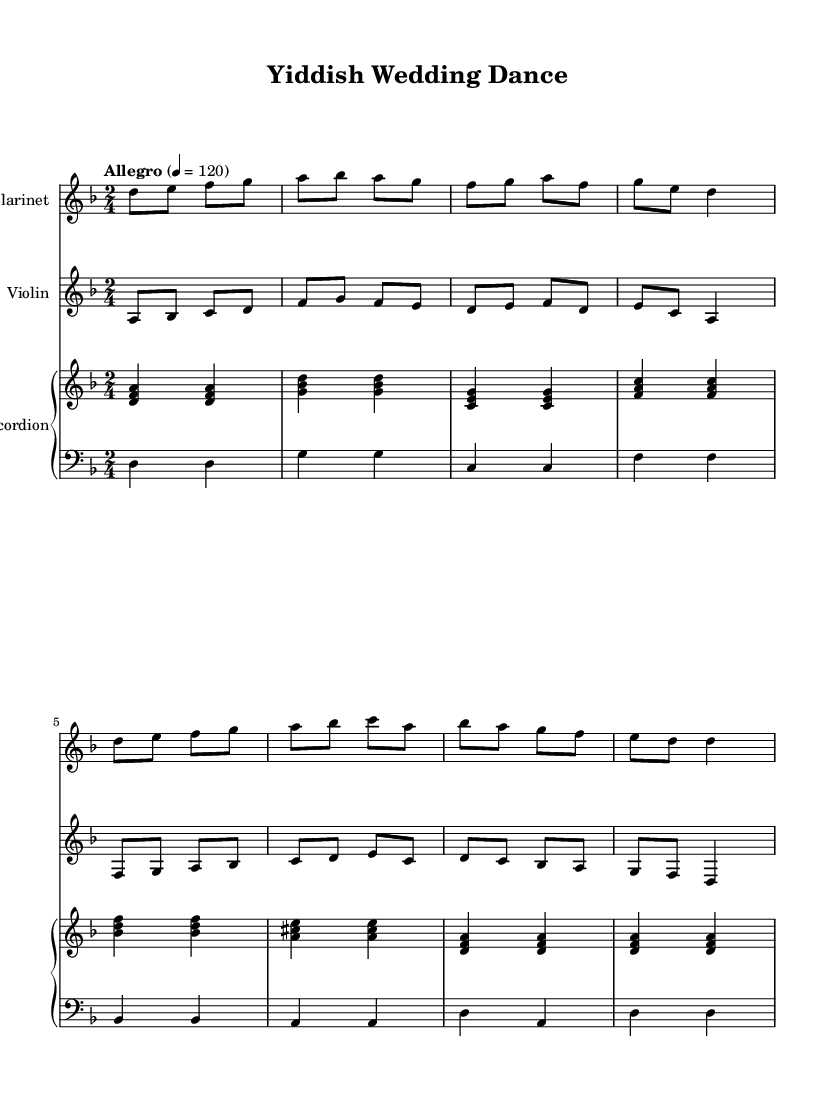What is the key signature of this music? The key signature indicates D minor, which has one flat (B flat). This is derived from the key signature shown at the beginning of the score.
Answer: D minor What is the time signature of this music? The time signature displayed at the beginning of the score is 2/4, meaning there are two beats per measure and the quarter note gets the beat.
Answer: 2/4 What is the tempo indication for this music? The tempo marked at the beginning is "Allegro" with a metronome marking of 120 beats per minute, suggesting a fast and lively pace.
Answer: Allegro, 120 How many staves are included in this score? There is a total of four staves present in this score: Clarinet, Violin, and a PianoStaff consisting of Accordion (treble and bass clefs).
Answer: Four Which instruments are featured in this arrangement? The instruments indicated in the score are Clarinet, Violin, and Accordion (which includes both treble and bass parts).
Answer: Clarinet, Violin, Accordion What style of music does this piece represent? This piece is representative of Klezmer folk music, often associated with festive celebrations and traditional Jewish weddings, as is suggested by the title "Yiddish Wedding Dance."
Answer: Klezmer folk music 